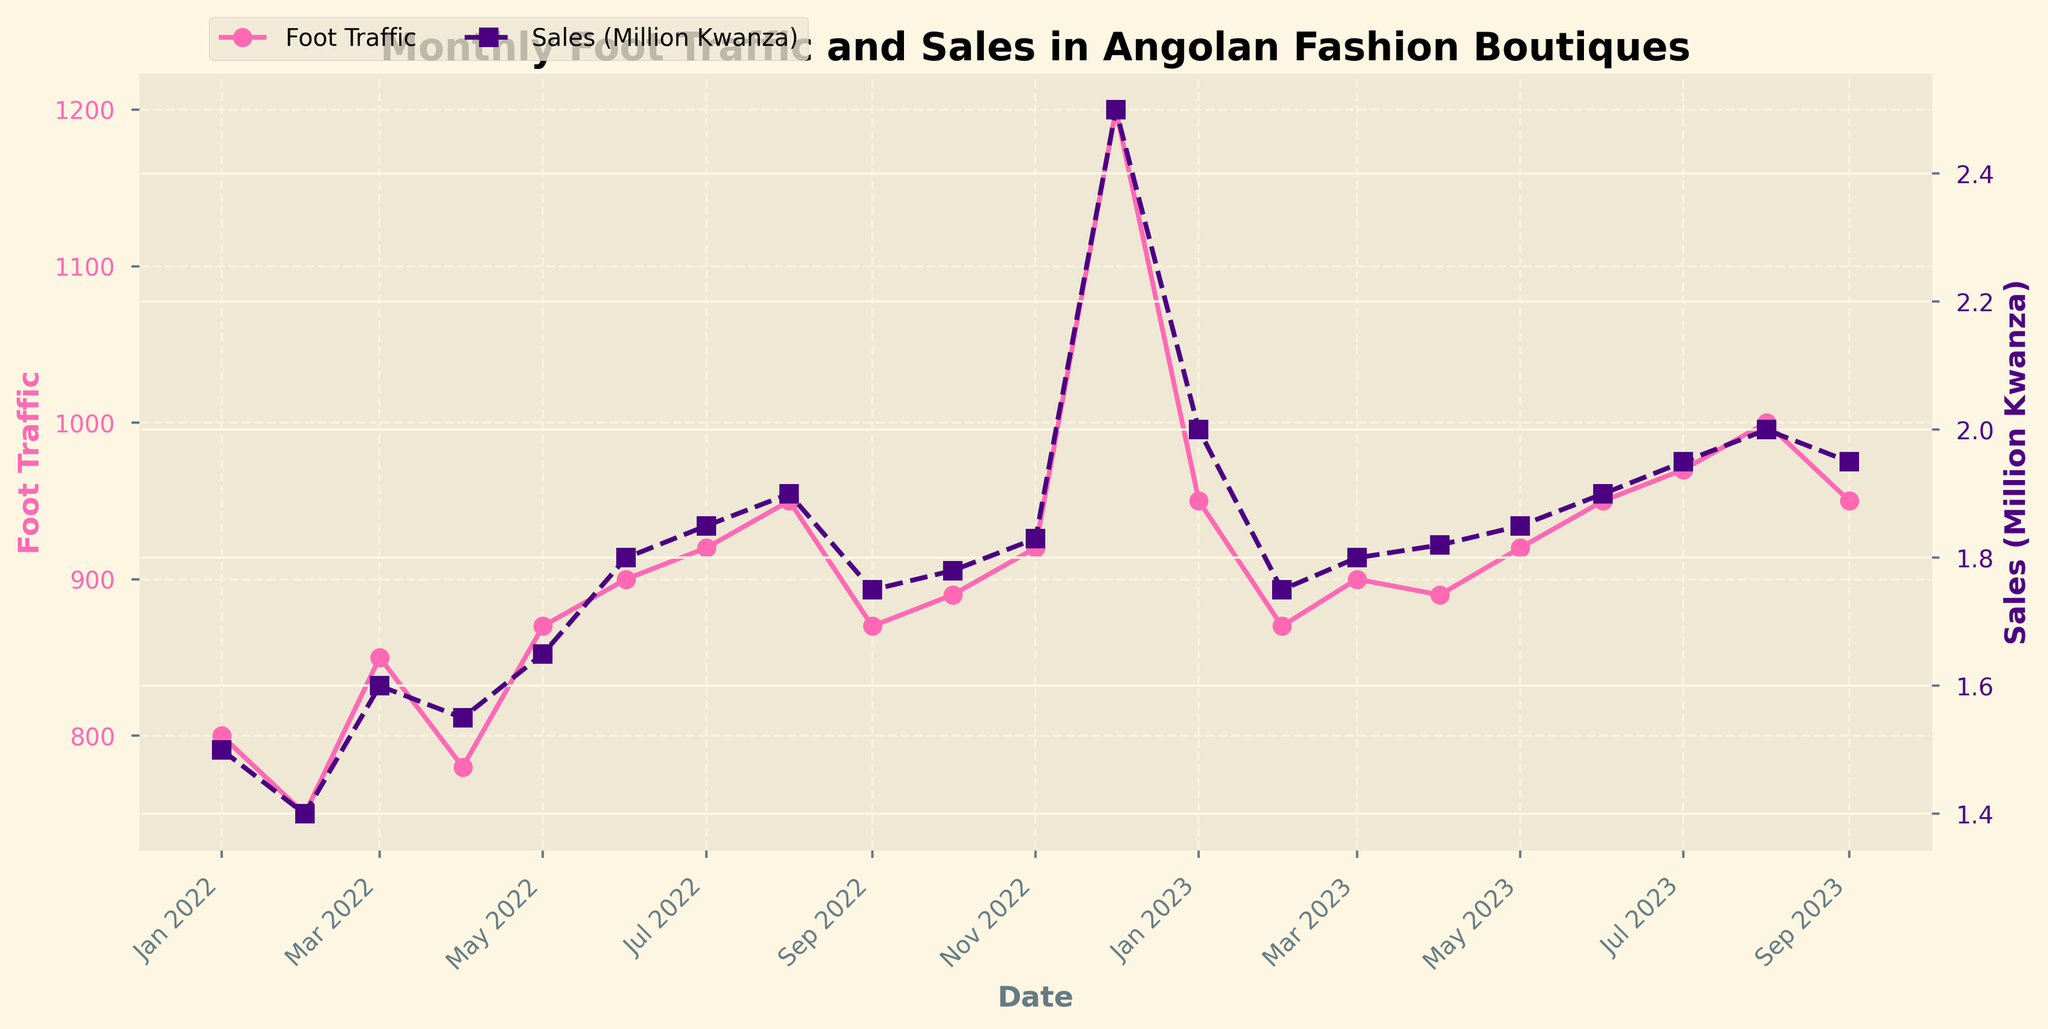What is the title of the plot? The title of the plot is usually found at the top of the chart. It summarizes the content of the visual representation.
Answer: Monthly Foot Traffic and Sales in Angolan Fashion Boutiques How many months does the plot cover? The x-axis represents the timeline and shows data from January 2022 to September 2023. Counting all unique months gives the total.
Answer: 21 Which month had the highest foot traffic? By looking at the highest point on the foot traffic line (pink line) on the plot, the peak is noted at December 2022.
Answer: December 2022 What are the units of sales on the secondary y-axis? The secondary y-axis on the right side shows sales in million Angolan Kwanza, as indicated by the label “Sales (Million Kwanza)”.
Answer: Million Kwanza Which month observed the highest sales value? The highest point on the sales line (purple line) indicates the maximum sales value. This peak is observed in December 2022.
Answer: December 2022 How does the sales trend appear from January 2022 to September 2023? Observing the overall trajectory of the sales line (purple line), sales generally increased with some fluctuations and a prominent peak in December 2022 before stabilizing.
Answer: Increasing with fluctuation What is the difference in foot traffic between the months with the highest and lowest traffic? The highest foot traffic is in December 2022 (1200), and the lowest traffic is in February 2022 (750). Subtracting these values gives the difference: 1200 - 750.
Answer: 450 Comparing July 2022 and July 2023, which month had higher sales? Comparing the sales values for July 2022 and July 2023 on the sales line (purple line), July 2023 shows a higher value.
Answer: July 2023 Did foot traffic and sales increase or decrease from October 2022 to November 2022? Examining the trends between October 2022 and November 2022, both the foot traffic (pink line) and sales (purple line) show an increase.
Answer: Increased How does foot traffic correlate with sales over the observed period? Both foot traffic and sales lines tend to rise and fall together over time. Peaks and troughs in both series often correspond to each other, indicating a positive correlation.
Answer: Positive correlation 